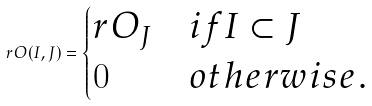Convert formula to latex. <formula><loc_0><loc_0><loc_500><loc_500>r O ( I , J ) = \begin{cases} r O _ { J } & i f I \subset J \\ 0 & o t h e r w i s e . \end{cases}</formula> 